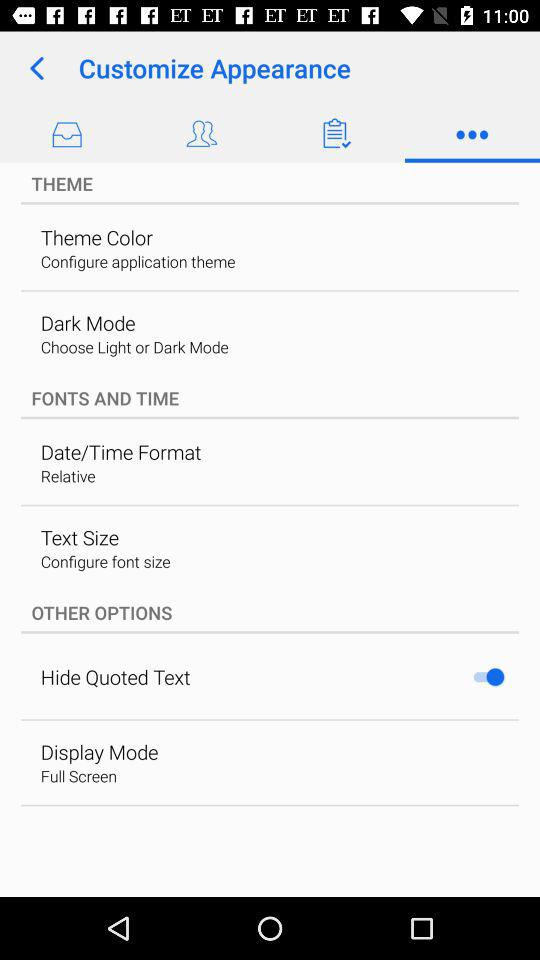Which tab has been selected? The tab that has been selected is "More". 